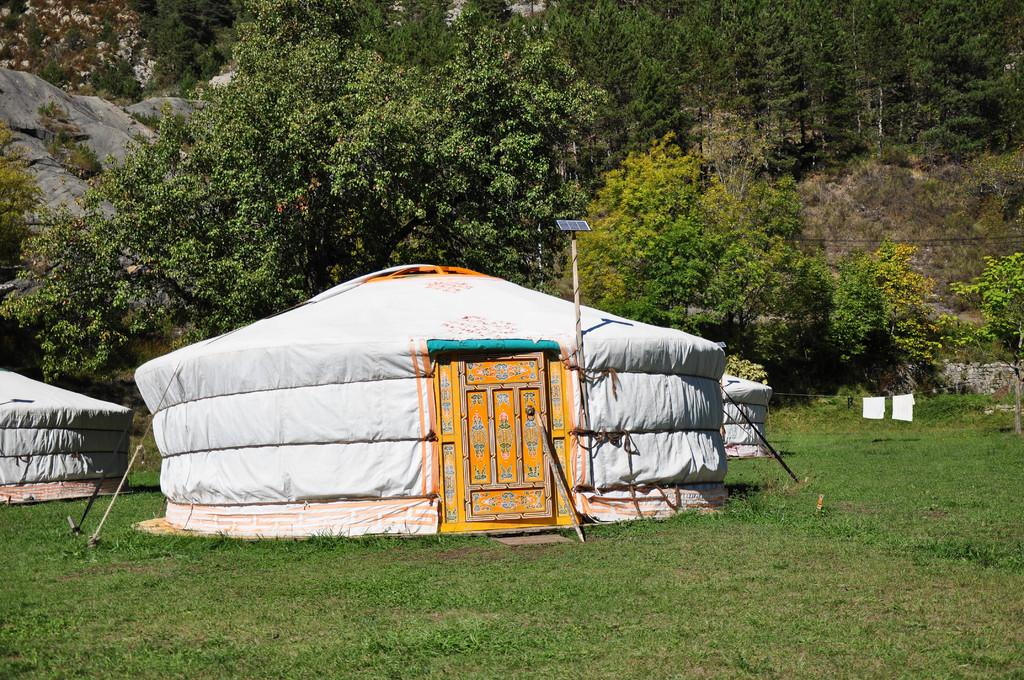What type of temporary shelters can be seen in the image? There are tents in the image. What device for generating electricity is present in the image? There is a solar panel in the image. What is being dried in the image? Clothes are hanged on a rope in the image. What type of natural vegetation is visible in the image? There are trees in the image. What are the cables used for in the image? The cables are present in the image, but their specific purpose is not mentioned. What type of natural geological formations are visible in the image? Rocks are visible in the image. What type of pencil can be seen being sharpened in the image? There is no pencil present in the image. What type of apple is being eaten by the person in the image? There is no person or apple present in the image. 